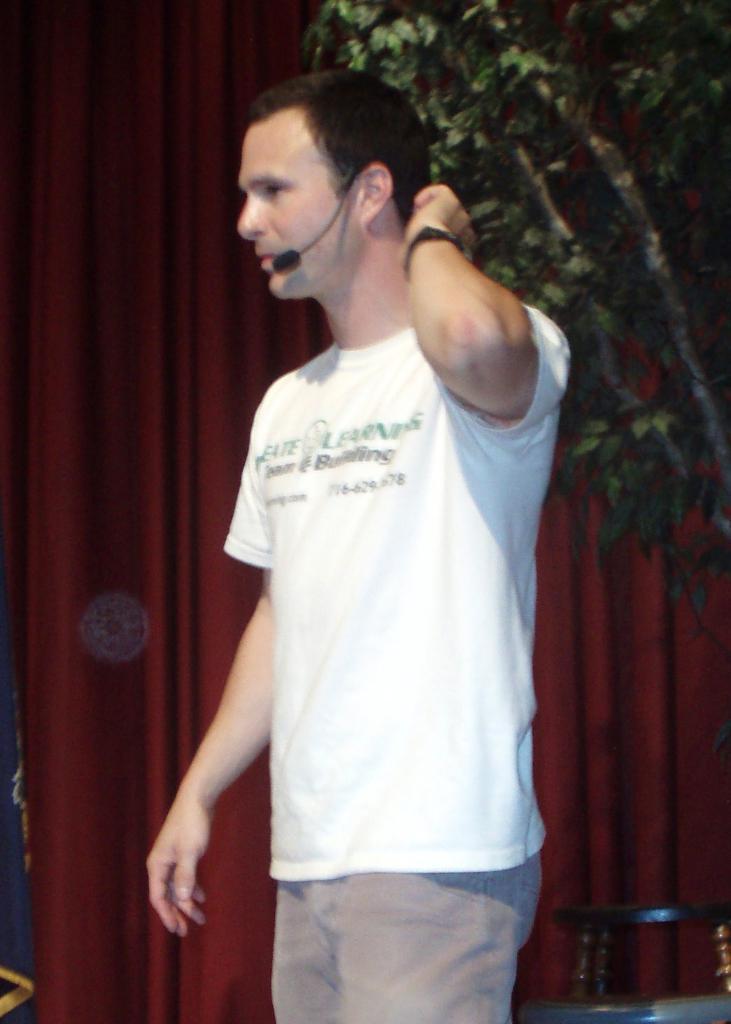Can you describe this image briefly? In this picture we can see a man and microphone, beside him we can see a chair, curtains and a tree. 